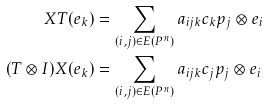Convert formula to latex. <formula><loc_0><loc_0><loc_500><loc_500>X T ( e _ { k } ) & = \sum _ { ( i , j ) \in E ( P ^ { n } ) } a _ { i j k } c _ { k } p _ { j } \otimes e _ { i } \\ ( T \otimes I ) X ( e _ { k } ) & = \sum _ { ( i , j ) \in E ( P ^ { n } ) } a _ { i j k } c _ { j } p _ { j } \otimes e _ { i }</formula> 